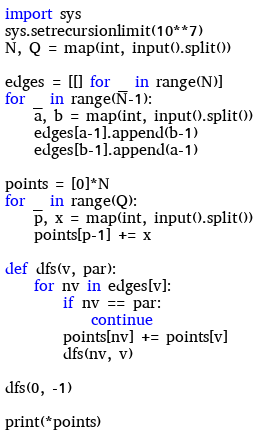<code> <loc_0><loc_0><loc_500><loc_500><_Python_>import sys
sys.setrecursionlimit(10**7)
N, Q = map(int, input().split())

edges = [[] for _ in range(N)]
for _ in range(N-1):
    a, b = map(int, input().split())
    edges[a-1].append(b-1)
    edges[b-1].append(a-1)

points = [0]*N
for _ in range(Q):
    p, x = map(int, input().split())
    points[p-1] += x

def dfs(v, par):
    for nv in edges[v]:
        if nv == par:
            continue
        points[nv] += points[v]
        dfs(nv, v)

dfs(0, -1)

print(*points)</code> 